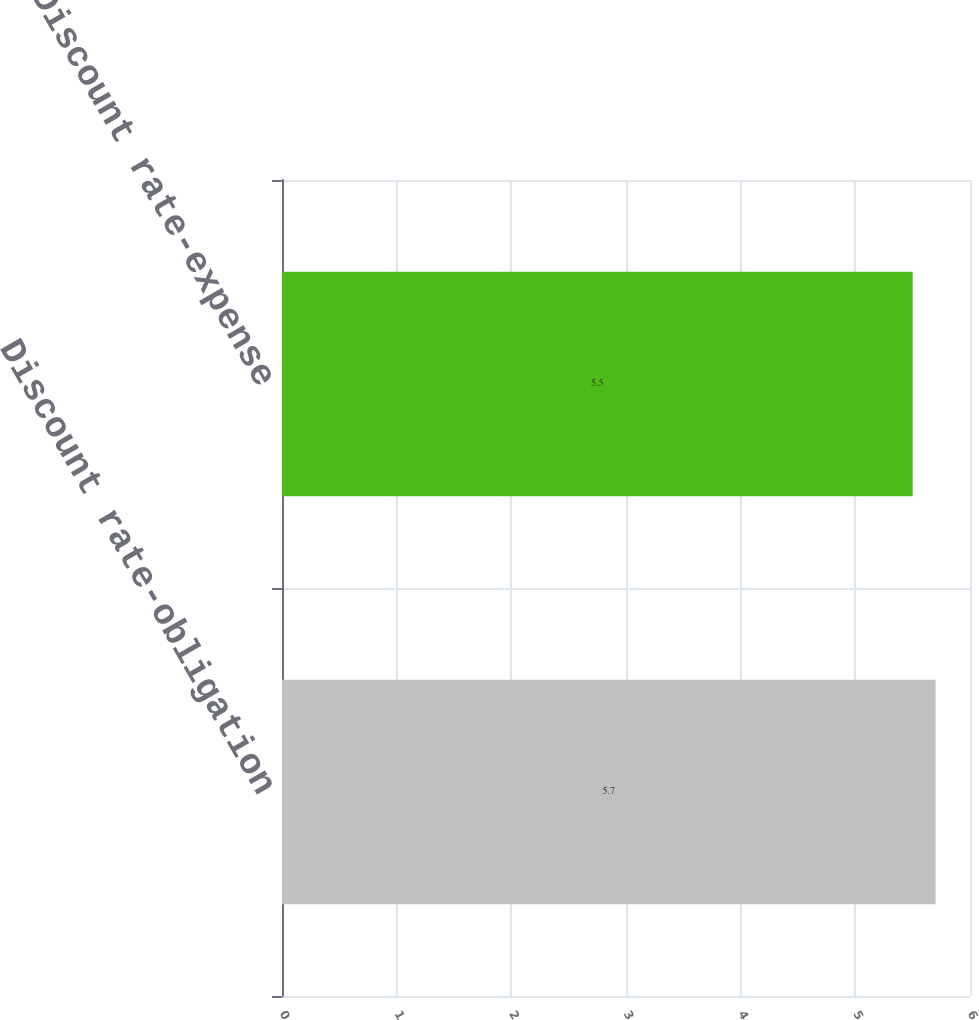Convert chart to OTSL. <chart><loc_0><loc_0><loc_500><loc_500><bar_chart><fcel>Discount rate-obligation<fcel>Discount rate-expense<nl><fcel>5.7<fcel>5.5<nl></chart> 